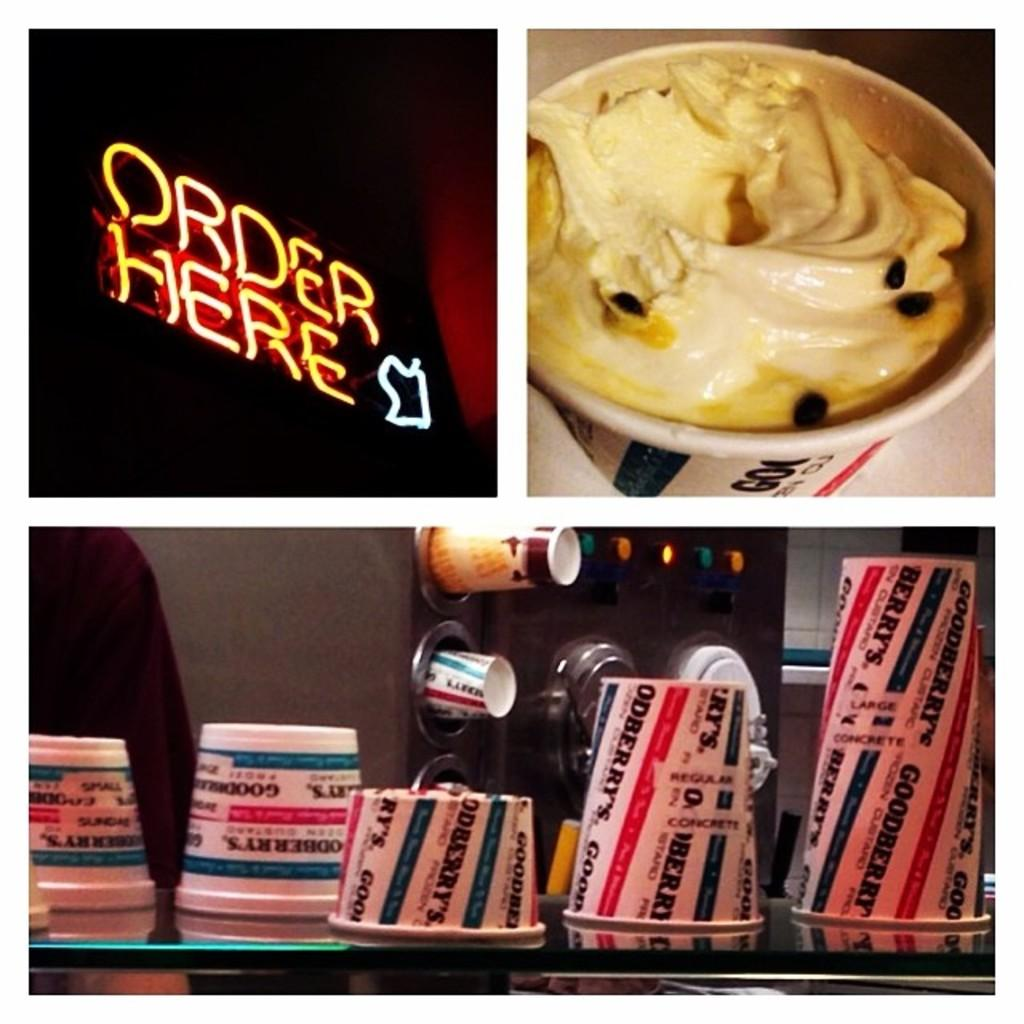<image>
Relay a brief, clear account of the picture shown. three different images with one reading order here and oanother with a cup of ice cream. 